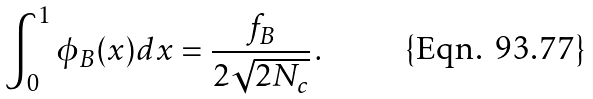<formula> <loc_0><loc_0><loc_500><loc_500>\int _ { 0 } ^ { 1 } \phi _ { B } ( x ) d x = \frac { f _ { B } } { 2 \sqrt { 2 N _ { c } } } \, .</formula> 